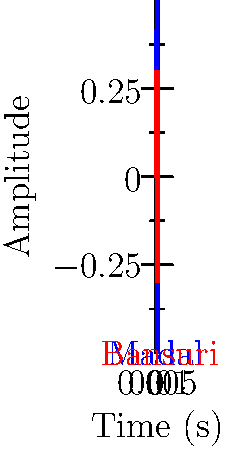During a traditional Nepalese festival, you record the sound waves from two instruments: a Madal (drum) and a Bansuri (flute). The graph shows the waveforms of both instruments. The Madal produces a frequency of 200 Hz. Based on the graph, what is the frequency of the Bansuri in Hz? To solve this problem, we need to follow these steps:

1. Observe that the period of a wave is the time for one complete cycle.
2. Note that frequency ($f$) is inversely proportional to the period ($T$): $f = \frac{1}{T}$
3. From the graph, we can see that:
   - The Madal (blue) completes 1 cycle in 0.005 seconds
   - The Bansuri (red) completes 1 cycle in 0.0025 seconds
4. We're given that the Madal frequency is 200 Hz. Let's verify:
   $f_{Madal} = \frac{1}{T_{Madal}} = \frac{1}{0.005 s} = 200 Hz$
5. Now, let's calculate the Bansuri frequency:
   $f_{Bansuri} = \frac{1}{T_{Bansuri}} = \frac{1}{0.0025 s} = 400 Hz$

Therefore, the frequency of the Bansuri is 400 Hz, which is twice the frequency of the Madal.
Answer: 400 Hz 